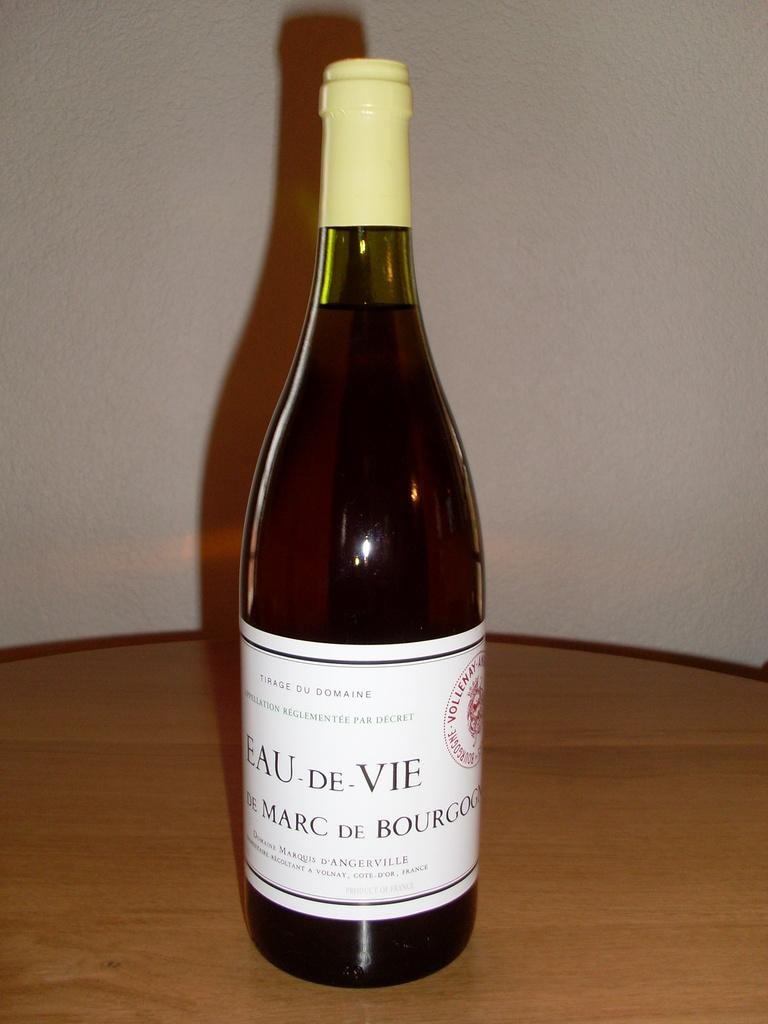What is this drink?
Your answer should be very brief. Eau de vie. 